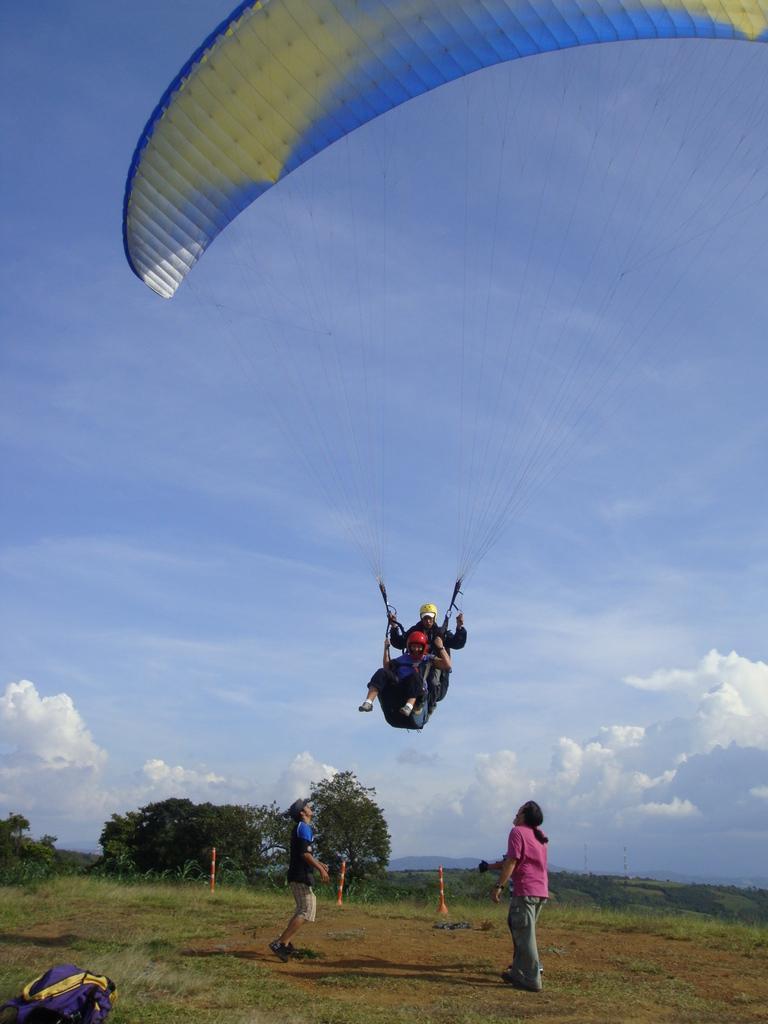Describe this image in one or two sentences. This image consists of four persons. At the bottom, there are two persons standing on the ground. And there is green grass on the ground. On the left, there is a backpack. In the background, there are trees. And two persons are flying in the sky with a parachute. At the top, there are clouds in the sky. 